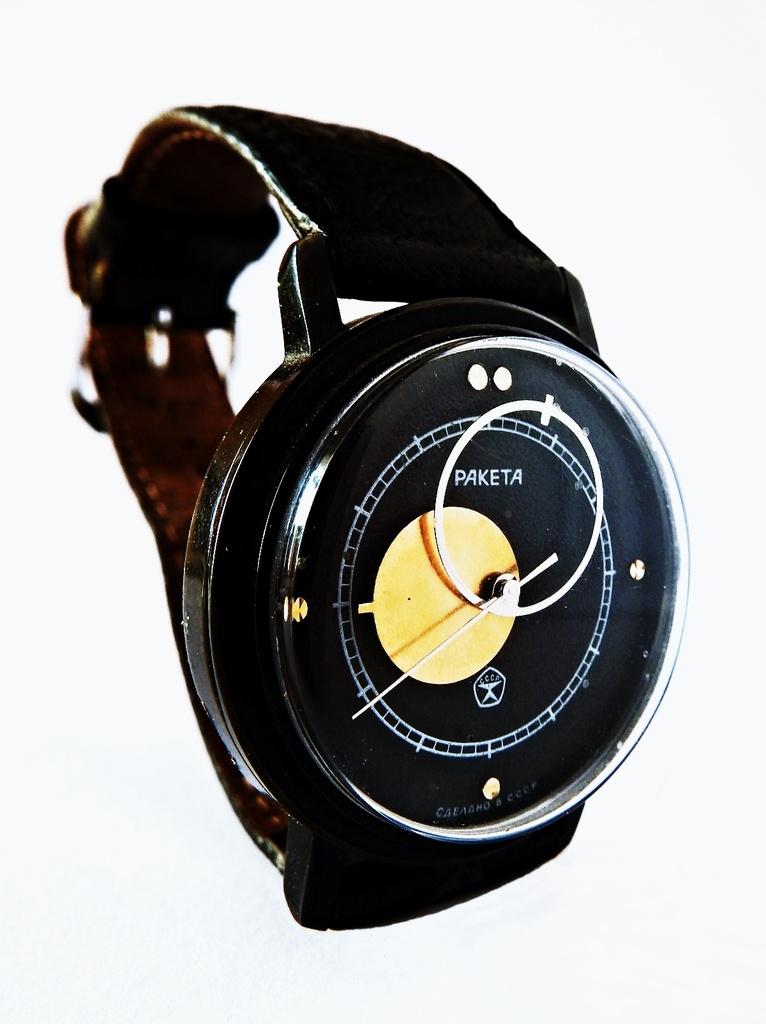What is the brand of this watch?
Ensure brevity in your answer.  Paketa. 